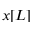Convert formula to latex. <formula><loc_0><loc_0><loc_500><loc_500>x [ L ]</formula> 